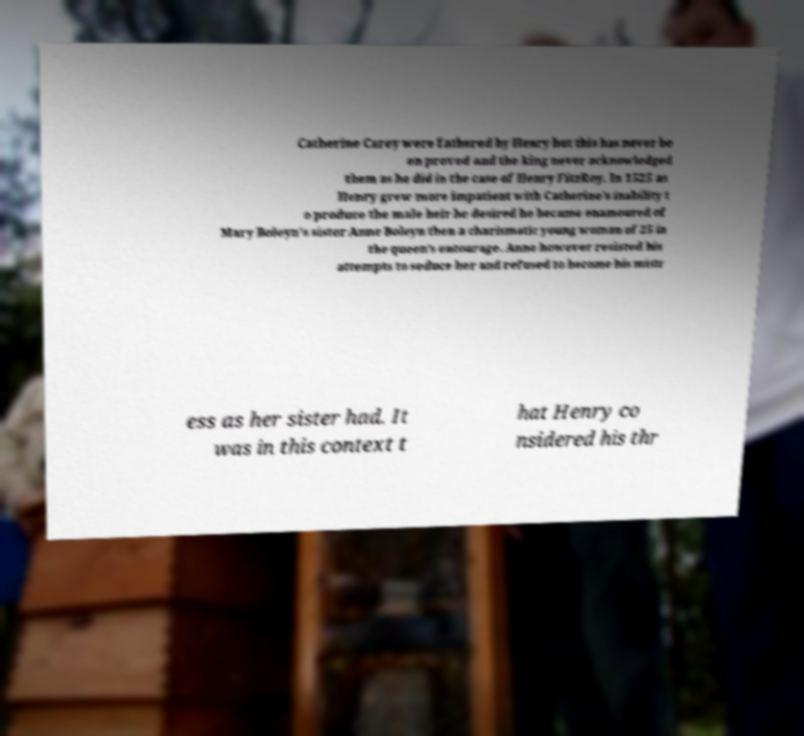There's text embedded in this image that I need extracted. Can you transcribe it verbatim? Catherine Carey were fathered by Henry but this has never be en proved and the king never acknowledged them as he did in the case of Henry FitzRoy. In 1525 as Henry grew more impatient with Catherine's inability t o produce the male heir he desired he became enamoured of Mary Boleyn's sister Anne Boleyn then a charismatic young woman of 25 in the queen's entourage. Anne however resisted his attempts to seduce her and refused to become his mistr ess as her sister had. It was in this context t hat Henry co nsidered his thr 